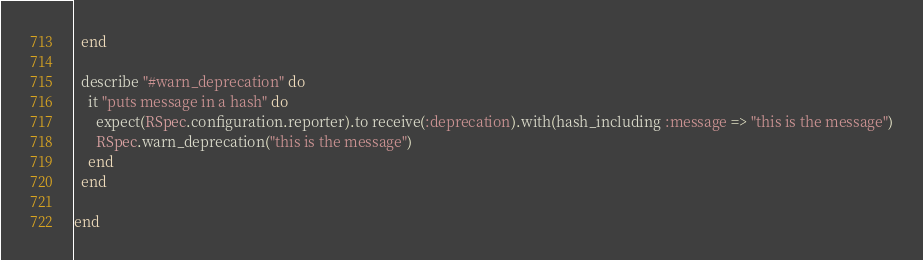Convert code to text. <code><loc_0><loc_0><loc_500><loc_500><_Ruby_>  end

  describe "#warn_deprecation" do
    it "puts message in a hash" do
      expect(RSpec.configuration.reporter).to receive(:deprecation).with(hash_including :message => "this is the message")
      RSpec.warn_deprecation("this is the message")
    end
  end

end
</code> 